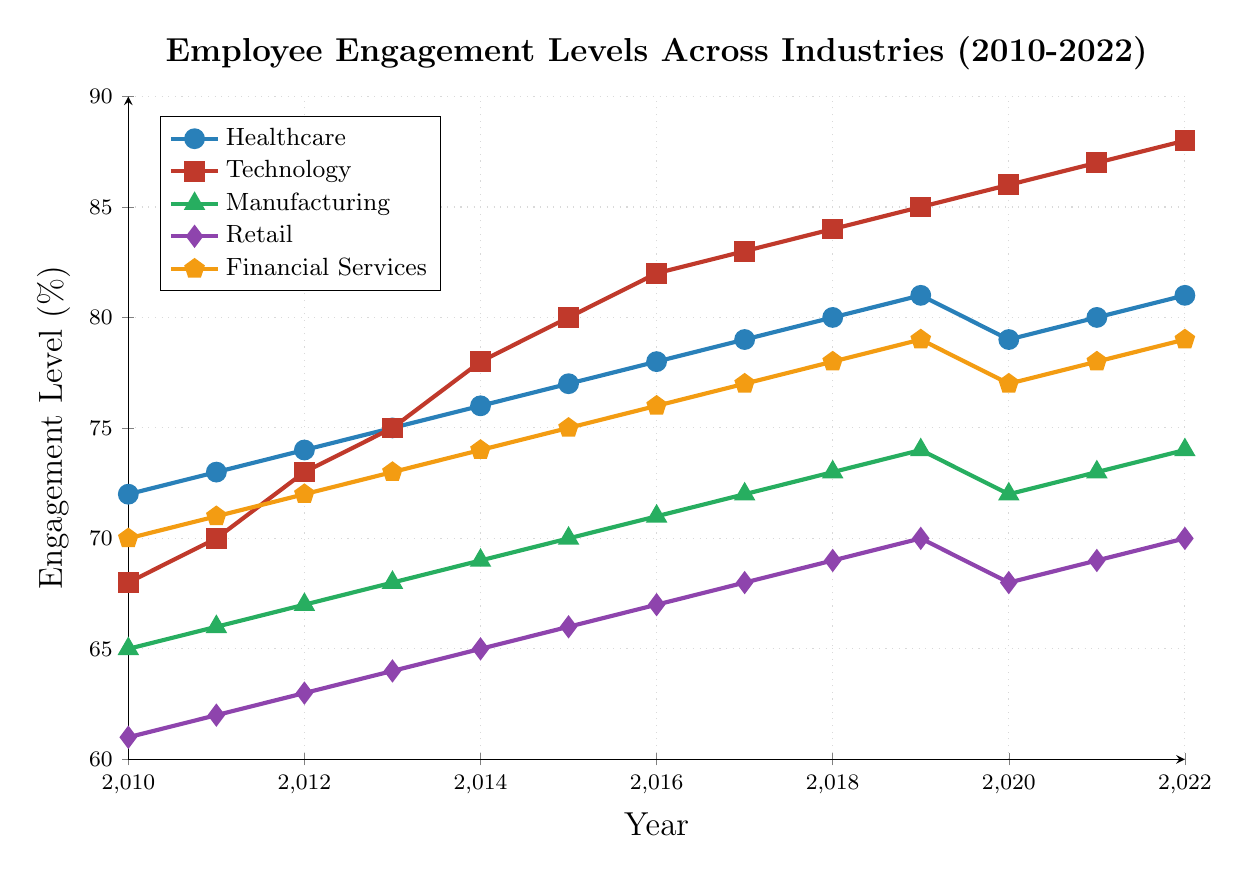Which industry had the highest employee engagement level in 2022? By examining the rightmost data points on the chart, we can see that the technology industry had the highest employee engagement level at 88% in 2022.
Answer: Technology Which industry showed the most significant increase in engagement from 2010 to 2022? By comparing the engagement levels from 2010 to 2022 across industries, we can see that the technology industry increased the most from 68% in 2010 to 88% in 2022, a 20% increase.
Answer: Technology What was the engagement level difference between the healthcare and retail industries in 2015? In 2015, the healthcare industry's engagement level was 77%, and the retail industry's engagement level was 66%. The difference is 77% - 66% = 11%.
Answer: 11% How did the engagement level of the financial services industry change from 2020 to 2022? The engagement level in financial services was 77% in 2020 and increased to 79% in 2022. Therefore, the change is 79% - 77% = 2%.
Answer: 2% Which industry had the lowest engagement level in 2018, and what was it? By examining the data points for 2018, the retail industry had the lowest engagement level at 69%.
Answer: Retail, 69% What was the average engagement level across all industries in 2020? The engagement levels for 2020 are Healthcare (79%), Technology (86%), Manufacturing (72%), Retail (68%), and Financial Services (77%). The average is (79 + 86 + 72 + 68 + 77) / 5 = 382 / 5 = 76.4%.
Answer: 76.4% Between 2014 and 2015, which industry showed the highest increase in employee engagement? By comparing the engagement levels between 2014 and 2015, the manufacturing industry increased from 69% to 70% (1%), retail from 65% to 66% (1%), healthcare from 76% to 77% (1%), financial services from 74% to 75% (1%), and technology from 78% to 80% (2%). The technology industry showed the highest increase of 2%.
Answer: Technology How did the engagement levels in the manufacturing industry trend from 2019 to 2020? In the manufacturing industry, the engagement level decreased from 2019 (74%) to 2020 (72%), hence it showed a declining trend.
Answer: Decreasing What is the difference in engagement levels between the healthcare and technology industries in 2020? The engagement level for healthcare in 2020 is 79%, and for technology, it is 86%. The difference is 86% - 79% = 7%.
Answer: 7% During which year did the retail industry reach an engagement level of 70%? By examining the data points, the retail industry reached an engagement level of 70% in 2019 and 2022.
Answer: 2019, 2022 